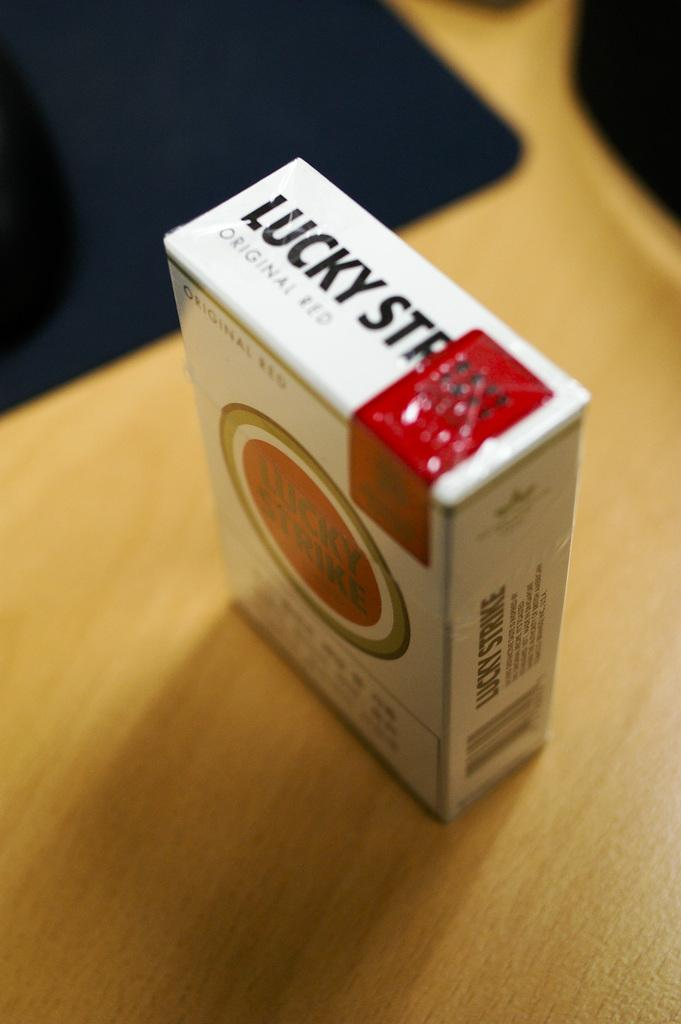<image>
Offer a succinct explanation of the picture presented. A package of Lucky Stripes with the seal still instact stands on a table. 